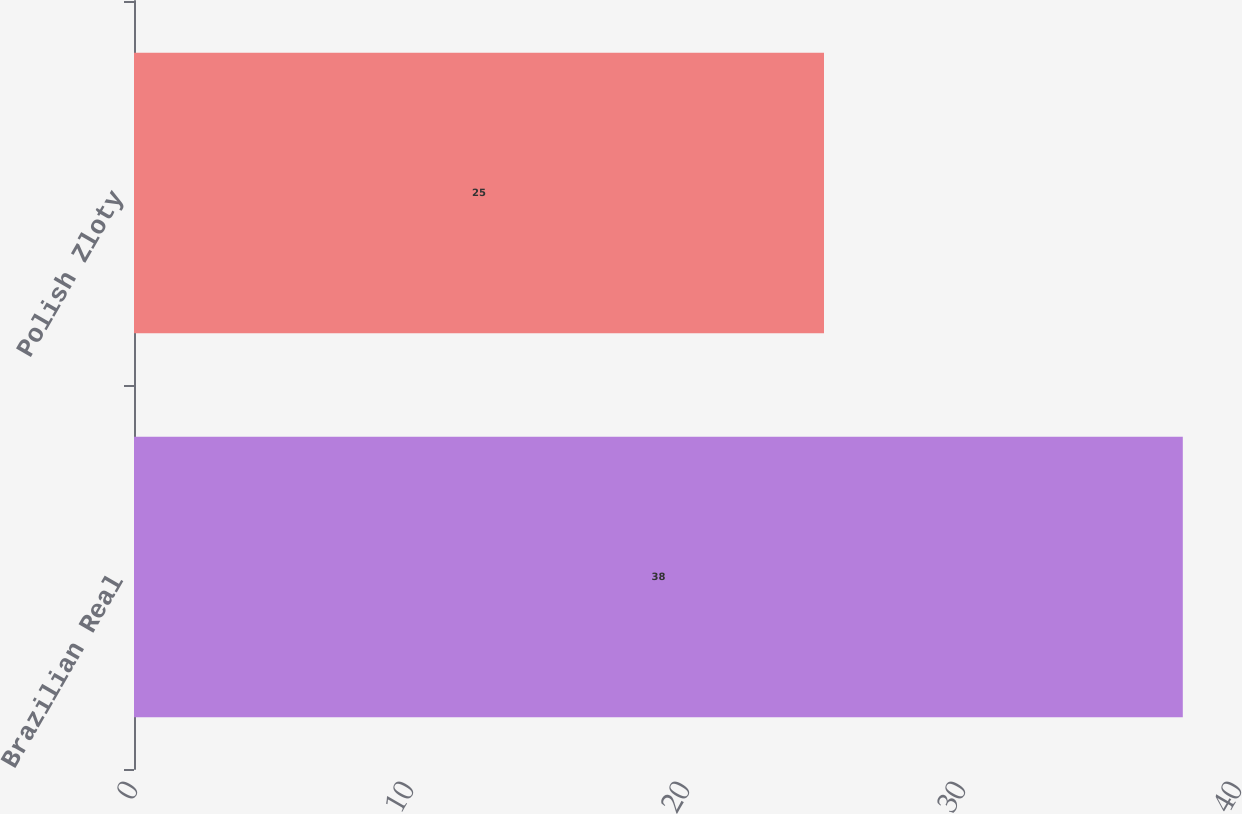Convert chart. <chart><loc_0><loc_0><loc_500><loc_500><bar_chart><fcel>Brazilian Real<fcel>Polish Zloty<nl><fcel>38<fcel>25<nl></chart> 